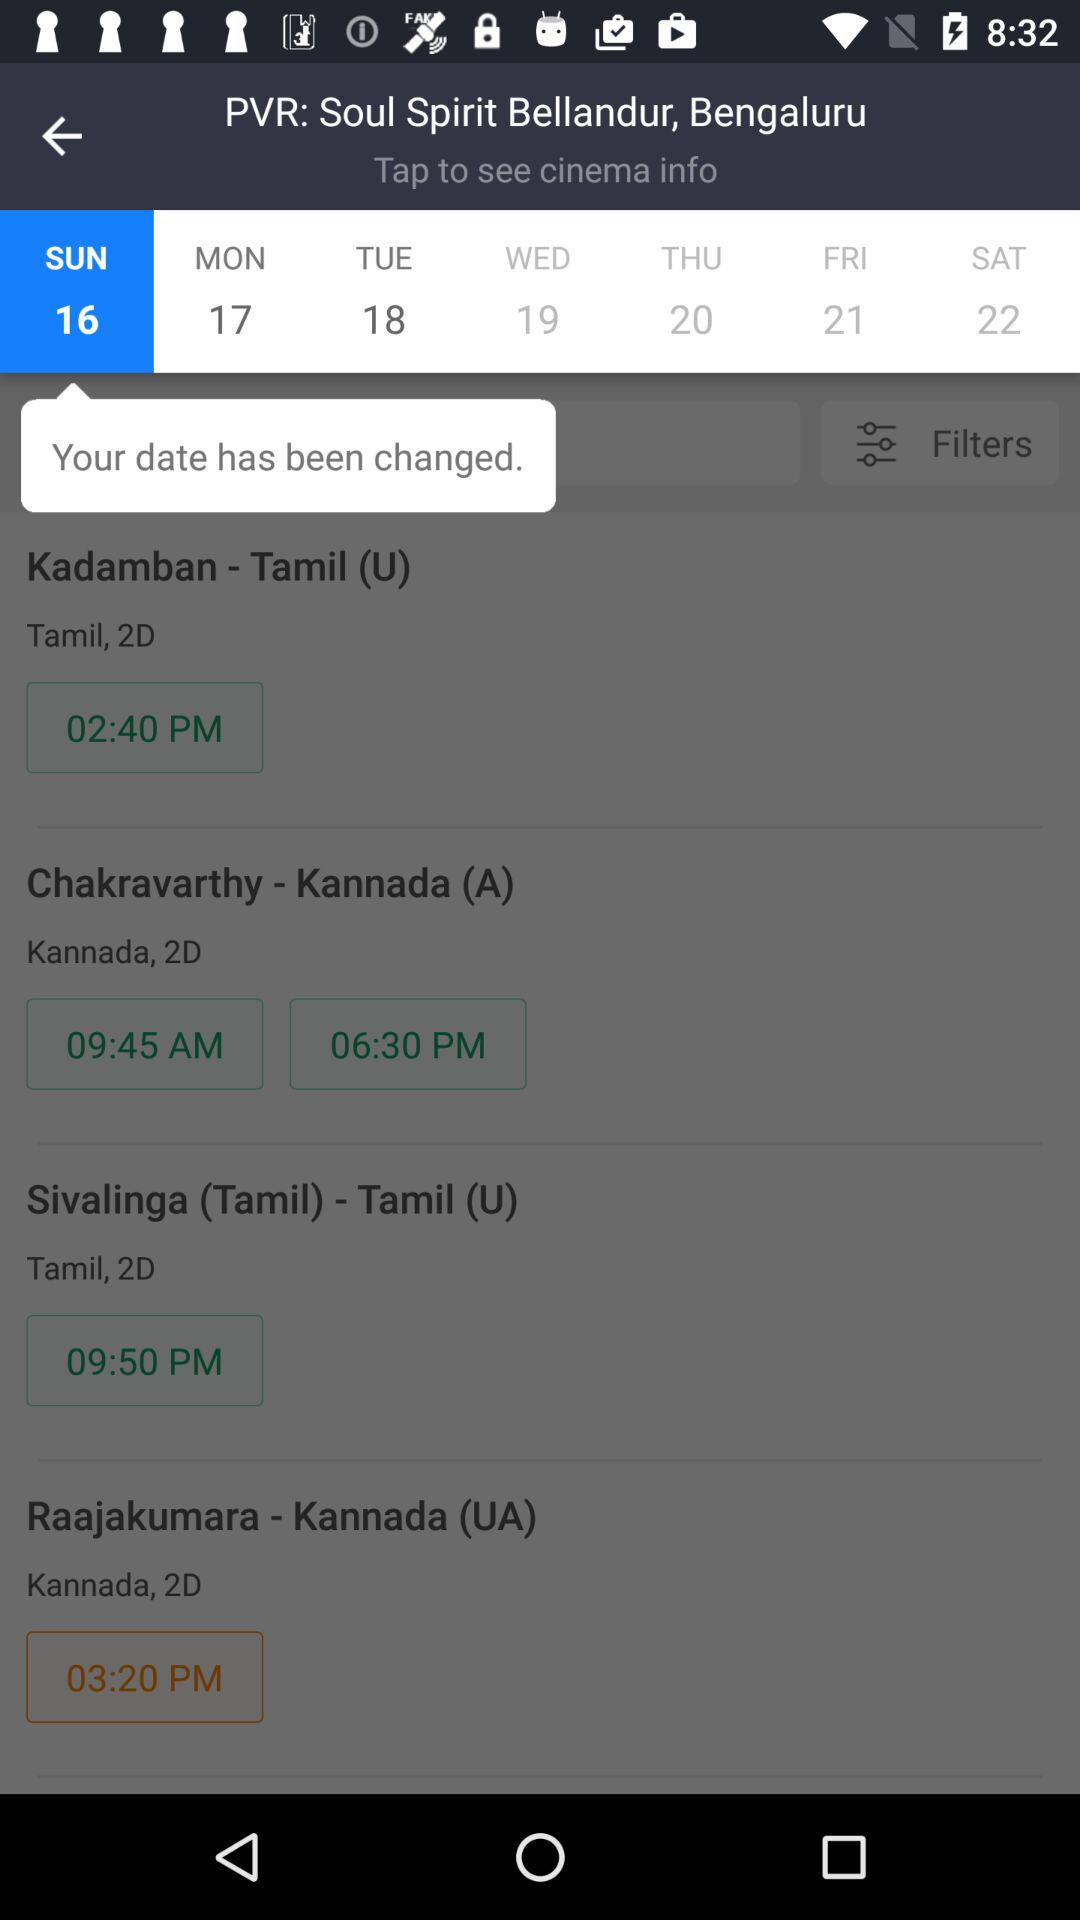What is the selected cinema? The selected cinema is "PVR: Soul Spirit Bellandur, Bengaluru". 